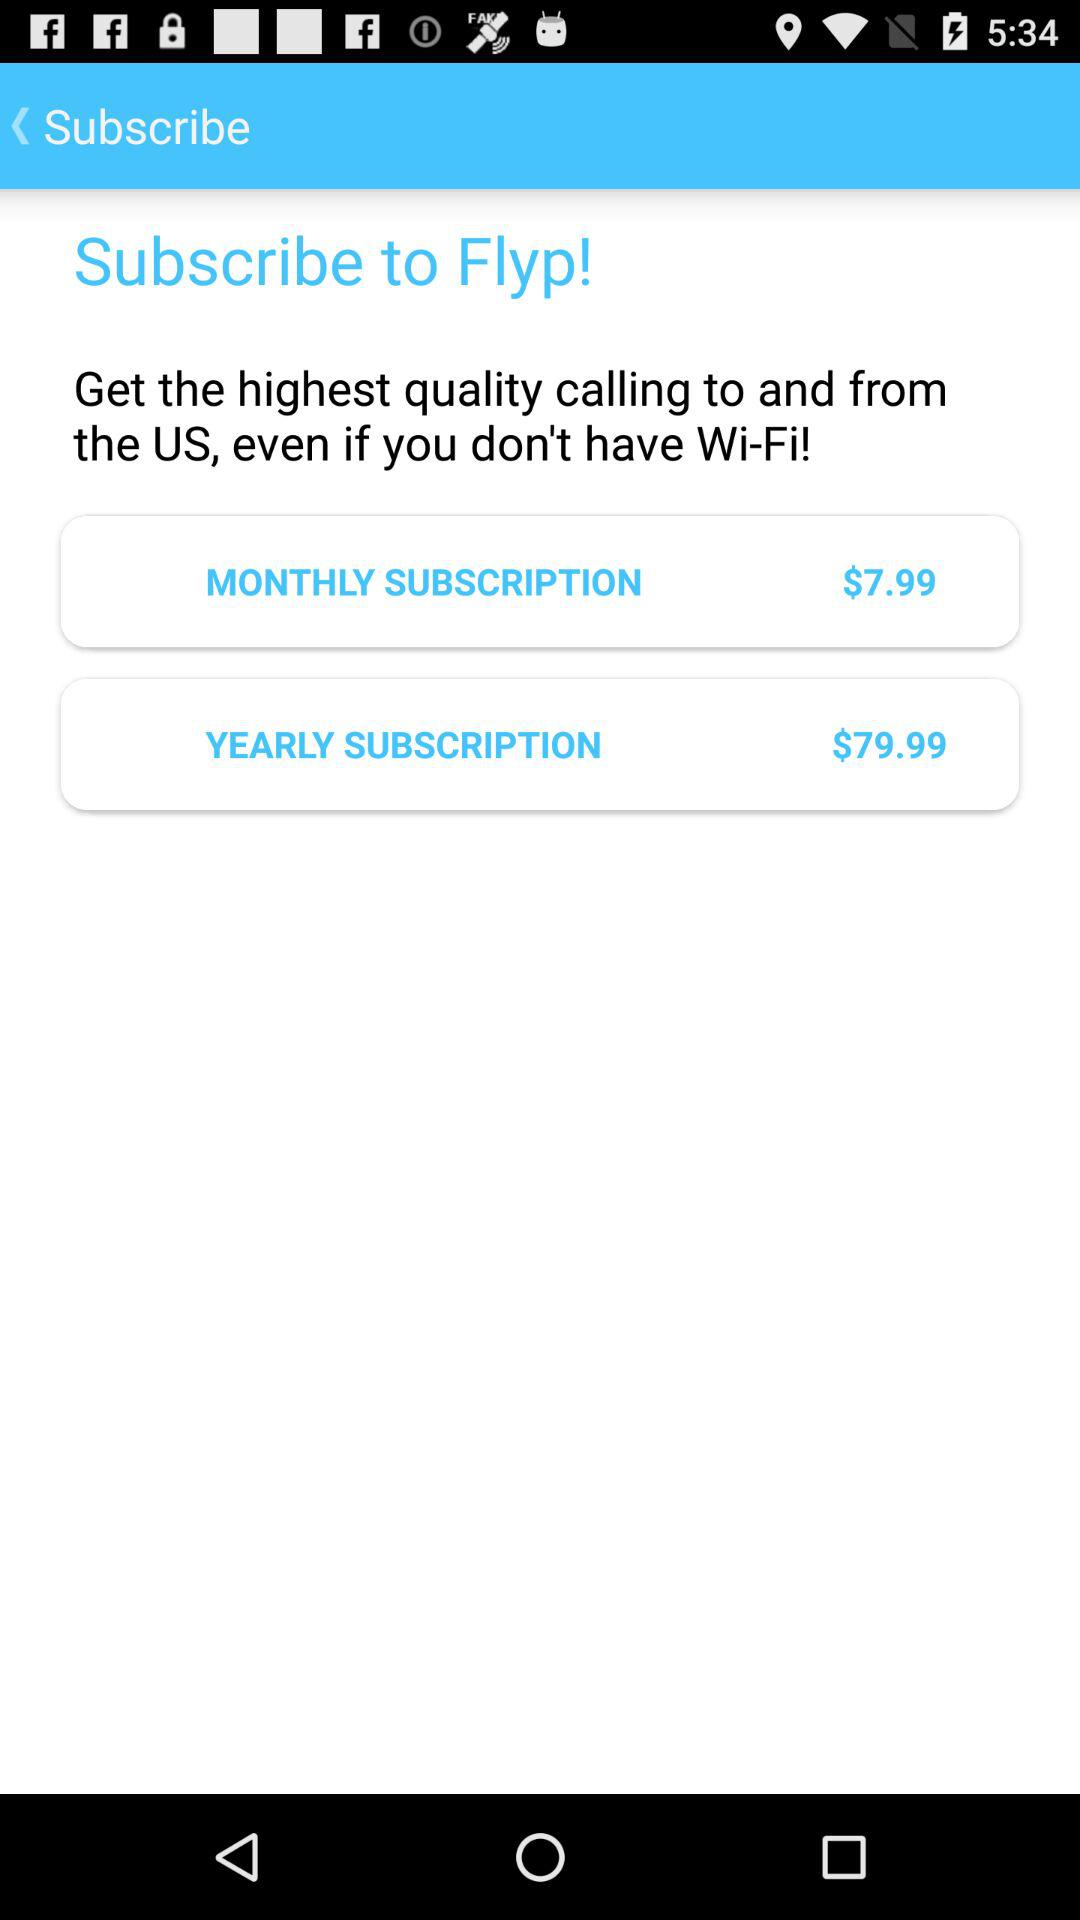What is the app name? The app name is "Flyp". 